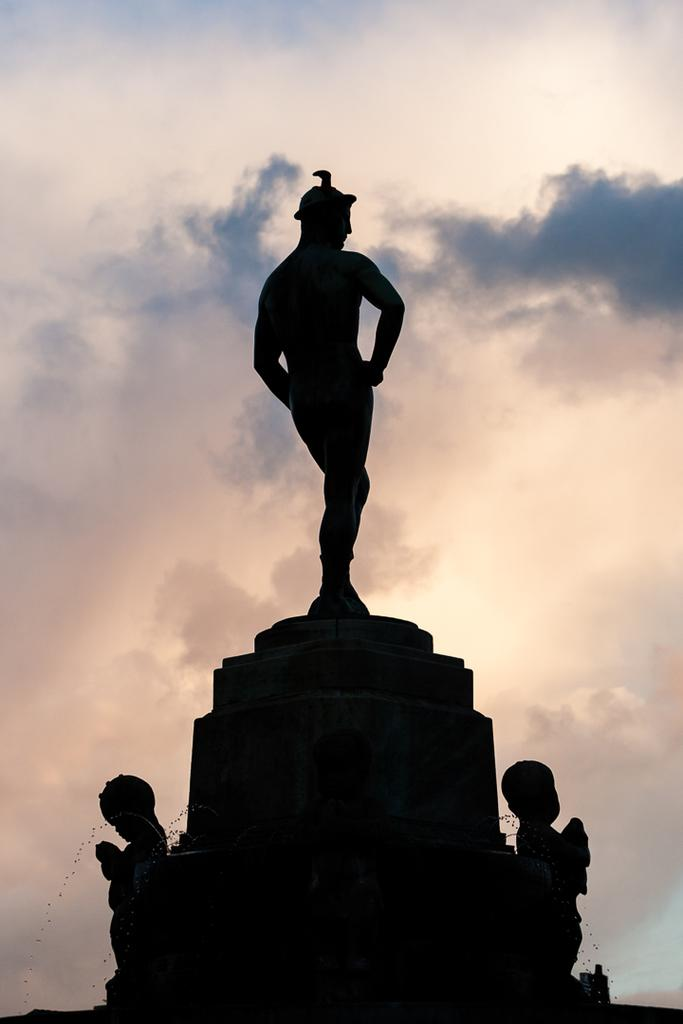What is the main subject of the picture? The main subject of the picture is a statue. What can be seen in the sky in the image? Clouds are visible in the sky. How many girls are holding a ring in the image? There are no girls or rings present in the image; it features a statue and clouds in the sky. What type of bean is growing near the statue in the image? There is no bean present in the image; it only features a statue and clouds in the sky. 